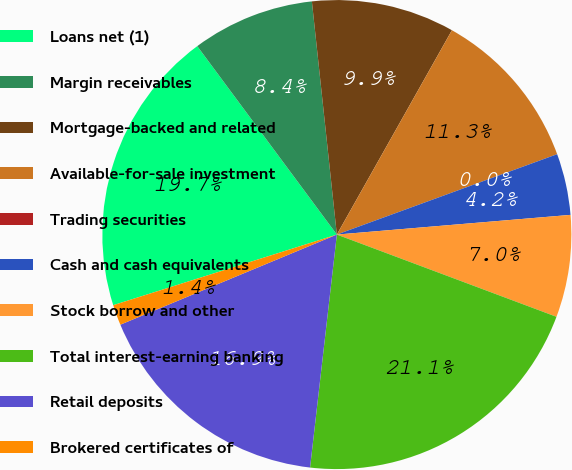Convert chart to OTSL. <chart><loc_0><loc_0><loc_500><loc_500><pie_chart><fcel>Loans net (1)<fcel>Margin receivables<fcel>Mortgage-backed and related<fcel>Available-for-sale investment<fcel>Trading securities<fcel>Cash and cash equivalents<fcel>Stock borrow and other<fcel>Total interest-earning banking<fcel>Retail deposits<fcel>Brokered certificates of<nl><fcel>19.72%<fcel>8.45%<fcel>9.86%<fcel>11.27%<fcel>0.0%<fcel>4.23%<fcel>7.04%<fcel>21.12%<fcel>16.9%<fcel>1.41%<nl></chart> 